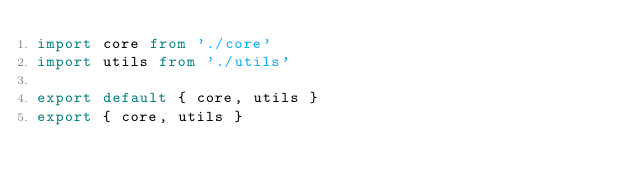<code> <loc_0><loc_0><loc_500><loc_500><_TypeScript_>import core from './core'
import utils from './utils'

export default { core, utils }
export { core, utils }
</code> 